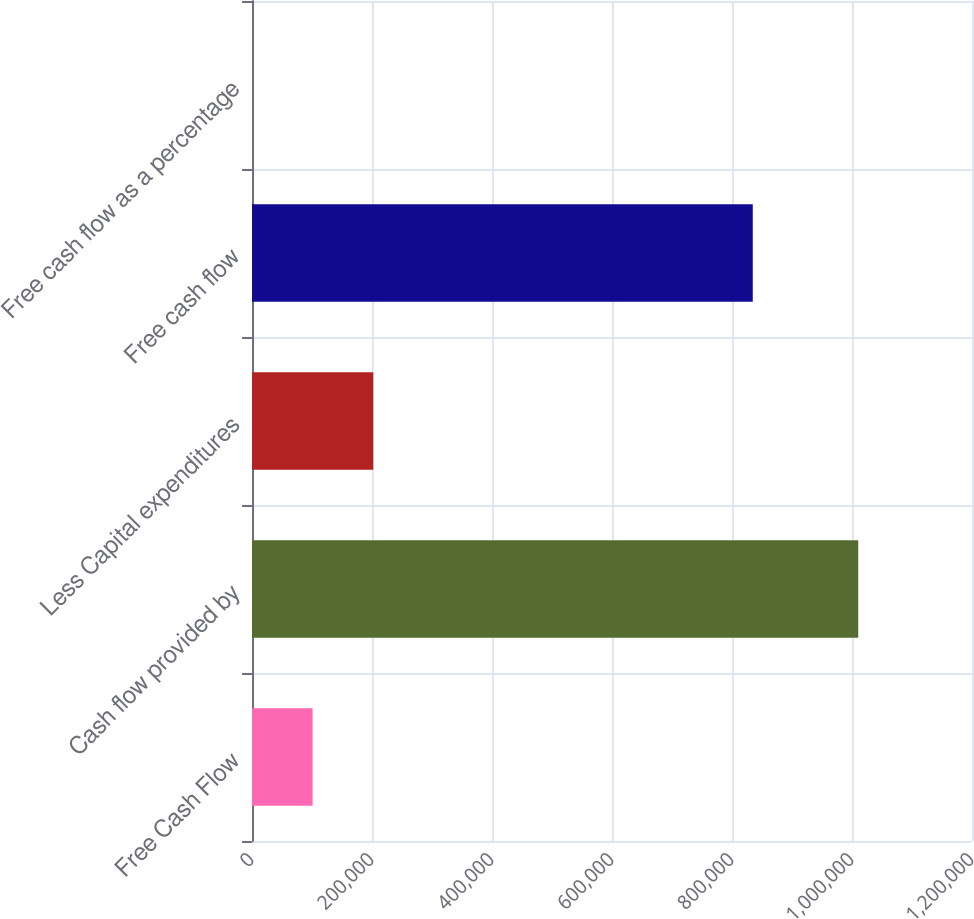Convert chart. <chart><loc_0><loc_0><loc_500><loc_500><bar_chart><fcel>Free Cash Flow<fcel>Cash flow provided by<fcel>Less Capital expenditures<fcel>Free cash flow<fcel>Free cash flow as a percentage<nl><fcel>101052<fcel>1.01042e+06<fcel>202092<fcel>834621<fcel>11<nl></chart> 